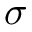<formula> <loc_0><loc_0><loc_500><loc_500>\sigma</formula> 